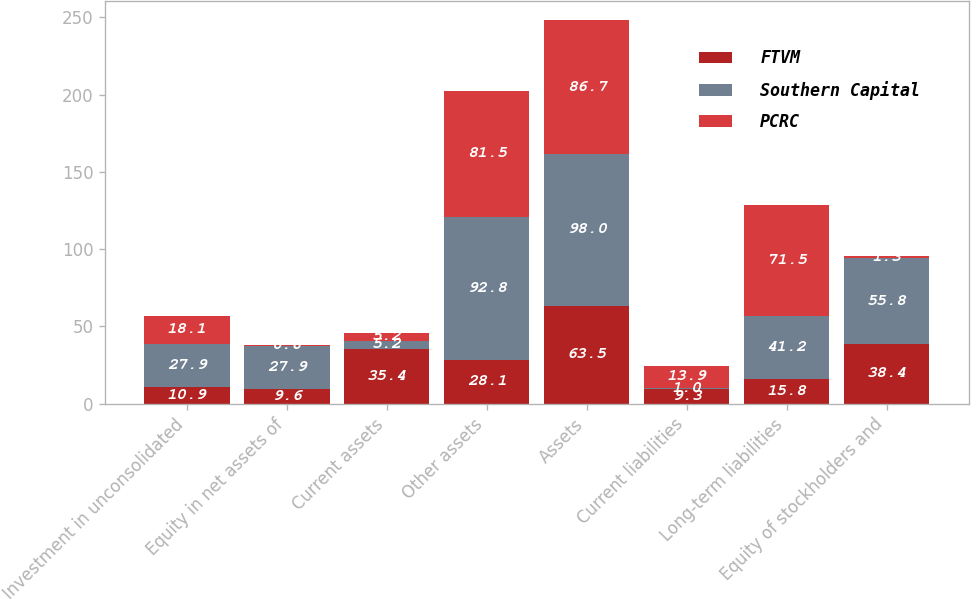Convert chart to OTSL. <chart><loc_0><loc_0><loc_500><loc_500><stacked_bar_chart><ecel><fcel>Investment in unconsolidated<fcel>Equity in net assets of<fcel>Current assets<fcel>Other assets<fcel>Assets<fcel>Current liabilities<fcel>Long-term liabilities<fcel>Equity of stockholders and<nl><fcel>FTVM<fcel>10.9<fcel>9.6<fcel>35.4<fcel>28.1<fcel>63.5<fcel>9.3<fcel>15.8<fcel>38.4<nl><fcel>Southern Capital<fcel>27.9<fcel>27.9<fcel>5.2<fcel>92.8<fcel>98<fcel>1<fcel>41.2<fcel>55.8<nl><fcel>PCRC<fcel>18.1<fcel>0.6<fcel>5.2<fcel>81.5<fcel>86.7<fcel>13.9<fcel>71.5<fcel>1.3<nl></chart> 